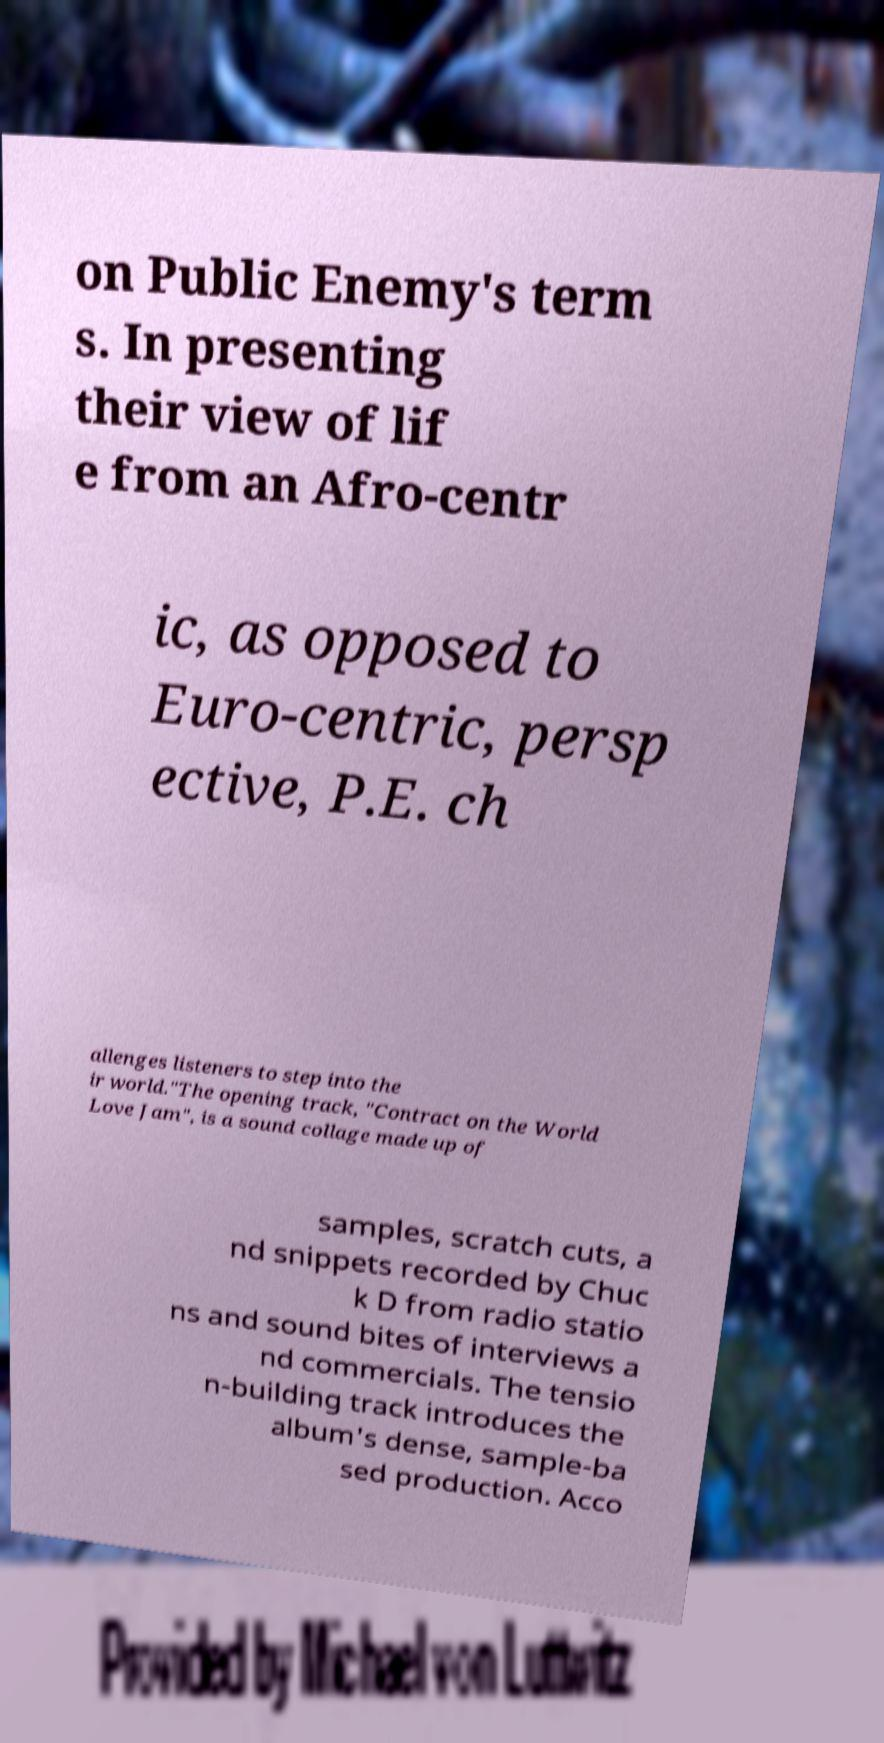For documentation purposes, I need the text within this image transcribed. Could you provide that? on Public Enemy's term s. In presenting their view of lif e from an Afro-centr ic, as opposed to Euro-centric, persp ective, P.E. ch allenges listeners to step into the ir world."The opening track, "Contract on the World Love Jam", is a sound collage made up of samples, scratch cuts, a nd snippets recorded by Chuc k D from radio statio ns and sound bites of interviews a nd commercials. The tensio n-building track introduces the album's dense, sample-ba sed production. Acco 